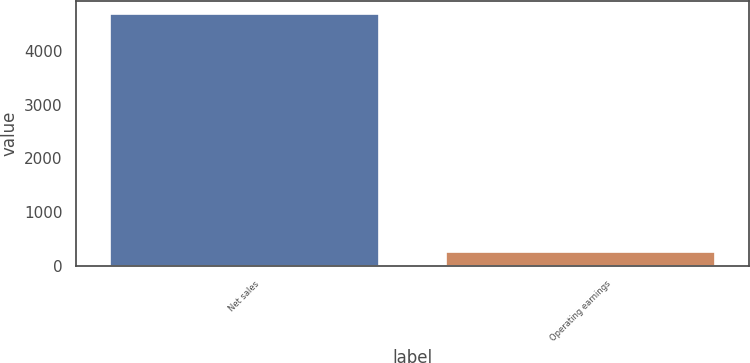<chart> <loc_0><loc_0><loc_500><loc_500><bar_chart><fcel>Net sales<fcel>Operating earnings<nl><fcel>4695<fcel>249<nl></chart> 